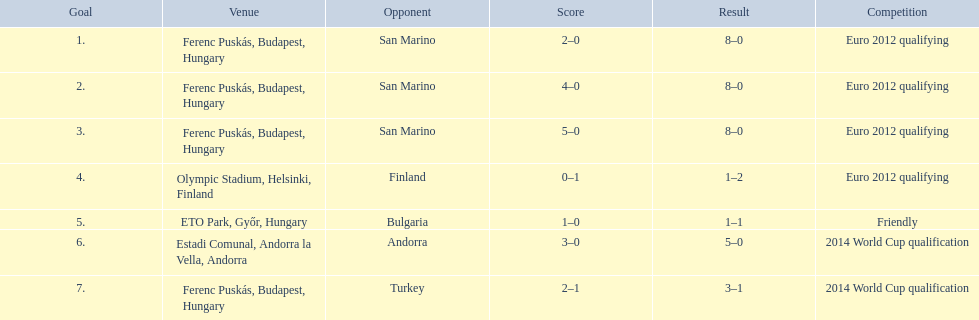Parse the full table. {'header': ['Goal', 'Venue', 'Opponent', 'Score', 'Result', 'Competition'], 'rows': [['1.', 'Ferenc Puskás, Budapest, Hungary', 'San Marino', '2–0', '8–0', 'Euro 2012 qualifying'], ['2.', 'Ferenc Puskás, Budapest, Hungary', 'San Marino', '4–0', '8–0', 'Euro 2012 qualifying'], ['3.', 'Ferenc Puskás, Budapest, Hungary', 'San Marino', '5–0', '8–0', 'Euro 2012 qualifying'], ['4.', 'Olympic Stadium, Helsinki, Finland', 'Finland', '0–1', '1–2', 'Euro 2012 qualifying'], ['5.', 'ETO Park, Győr, Hungary', 'Bulgaria', '1–0', '1–1', 'Friendly'], ['6.', 'Estadi Comunal, Andorra la Vella, Andorra', 'Andorra', '3–0', '5–0', '2014 World Cup qualification'], ['7.', 'Ferenc Puskás, Budapest, Hungary', 'Turkey', '2–1', '3–1', '2014 World Cup qualification']]} After 2010, during which year did ádám szalai achieve his next international goal? 2012. 